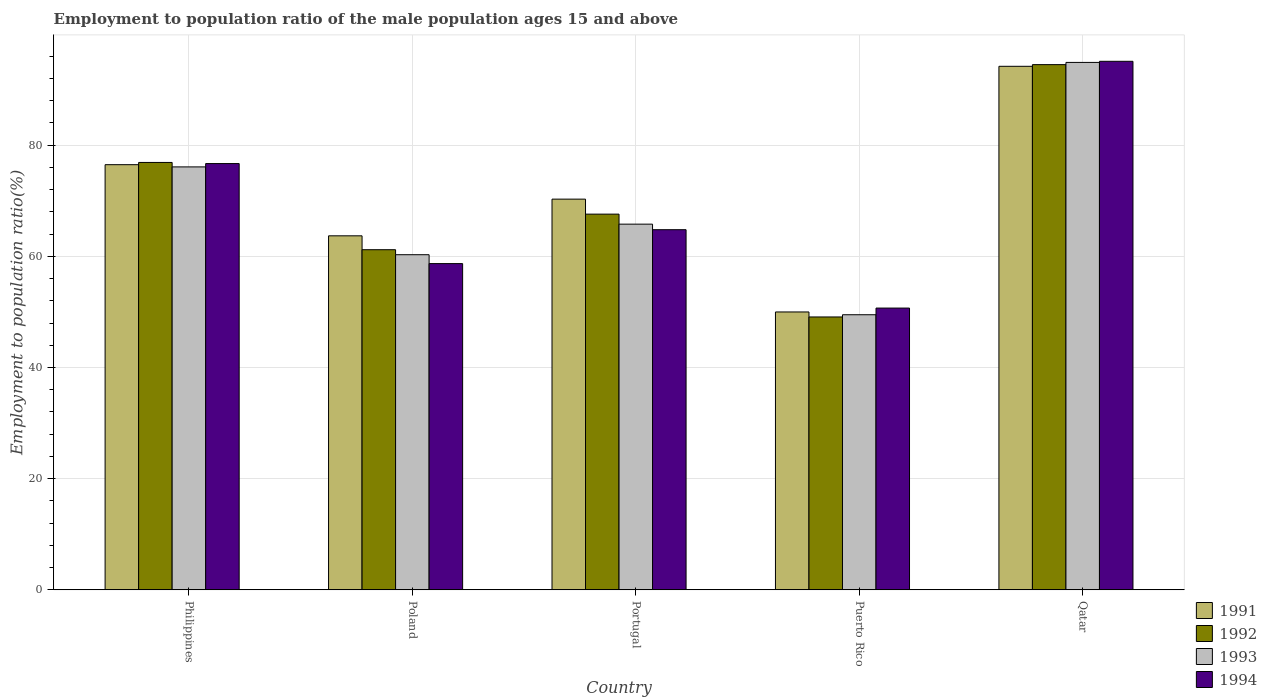How many different coloured bars are there?
Give a very brief answer. 4. How many groups of bars are there?
Your response must be concise. 5. Are the number of bars per tick equal to the number of legend labels?
Your answer should be very brief. Yes. How many bars are there on the 2nd tick from the right?
Your response must be concise. 4. What is the label of the 5th group of bars from the left?
Offer a terse response. Qatar. What is the employment to population ratio in 1991 in Qatar?
Keep it short and to the point. 94.2. Across all countries, what is the maximum employment to population ratio in 1992?
Ensure brevity in your answer.  94.5. Across all countries, what is the minimum employment to population ratio in 1993?
Ensure brevity in your answer.  49.5. In which country was the employment to population ratio in 1992 maximum?
Provide a succinct answer. Qatar. In which country was the employment to population ratio in 1993 minimum?
Provide a short and direct response. Puerto Rico. What is the total employment to population ratio in 1992 in the graph?
Your answer should be very brief. 349.3. What is the difference between the employment to population ratio in 1992 in Poland and that in Portugal?
Make the answer very short. -6.4. What is the difference between the employment to population ratio in 1993 in Qatar and the employment to population ratio in 1994 in Philippines?
Ensure brevity in your answer.  18.2. What is the average employment to population ratio in 1992 per country?
Offer a terse response. 69.86. In how many countries, is the employment to population ratio in 1994 greater than 44 %?
Offer a very short reply. 5. What is the ratio of the employment to population ratio in 1991 in Poland to that in Qatar?
Your answer should be compact. 0.68. Is the difference between the employment to population ratio in 1992 in Philippines and Qatar greater than the difference between the employment to population ratio in 1991 in Philippines and Qatar?
Keep it short and to the point. Yes. What is the difference between the highest and the second highest employment to population ratio in 1994?
Offer a very short reply. -11.9. What is the difference between the highest and the lowest employment to population ratio in 1992?
Your answer should be compact. 45.4. How many bars are there?
Provide a succinct answer. 20. Are all the bars in the graph horizontal?
Provide a short and direct response. No. How many countries are there in the graph?
Your response must be concise. 5. Where does the legend appear in the graph?
Give a very brief answer. Bottom right. How many legend labels are there?
Provide a succinct answer. 4. What is the title of the graph?
Make the answer very short. Employment to population ratio of the male population ages 15 and above. Does "1964" appear as one of the legend labels in the graph?
Provide a short and direct response. No. What is the Employment to population ratio(%) of 1991 in Philippines?
Provide a succinct answer. 76.5. What is the Employment to population ratio(%) of 1992 in Philippines?
Keep it short and to the point. 76.9. What is the Employment to population ratio(%) of 1993 in Philippines?
Keep it short and to the point. 76.1. What is the Employment to population ratio(%) in 1994 in Philippines?
Provide a short and direct response. 76.7. What is the Employment to population ratio(%) of 1991 in Poland?
Offer a very short reply. 63.7. What is the Employment to population ratio(%) in 1992 in Poland?
Keep it short and to the point. 61.2. What is the Employment to population ratio(%) in 1993 in Poland?
Offer a very short reply. 60.3. What is the Employment to population ratio(%) in 1994 in Poland?
Make the answer very short. 58.7. What is the Employment to population ratio(%) in 1991 in Portugal?
Provide a short and direct response. 70.3. What is the Employment to population ratio(%) in 1992 in Portugal?
Offer a terse response. 67.6. What is the Employment to population ratio(%) of 1993 in Portugal?
Provide a succinct answer. 65.8. What is the Employment to population ratio(%) of 1994 in Portugal?
Provide a succinct answer. 64.8. What is the Employment to population ratio(%) of 1991 in Puerto Rico?
Your answer should be compact. 50. What is the Employment to population ratio(%) in 1992 in Puerto Rico?
Your answer should be compact. 49.1. What is the Employment to population ratio(%) of 1993 in Puerto Rico?
Your response must be concise. 49.5. What is the Employment to population ratio(%) in 1994 in Puerto Rico?
Ensure brevity in your answer.  50.7. What is the Employment to population ratio(%) in 1991 in Qatar?
Your response must be concise. 94.2. What is the Employment to population ratio(%) of 1992 in Qatar?
Your answer should be compact. 94.5. What is the Employment to population ratio(%) in 1993 in Qatar?
Ensure brevity in your answer.  94.9. What is the Employment to population ratio(%) in 1994 in Qatar?
Provide a succinct answer. 95.1. Across all countries, what is the maximum Employment to population ratio(%) of 1991?
Offer a very short reply. 94.2. Across all countries, what is the maximum Employment to population ratio(%) in 1992?
Provide a short and direct response. 94.5. Across all countries, what is the maximum Employment to population ratio(%) of 1993?
Your response must be concise. 94.9. Across all countries, what is the maximum Employment to population ratio(%) in 1994?
Ensure brevity in your answer.  95.1. Across all countries, what is the minimum Employment to population ratio(%) in 1991?
Your answer should be very brief. 50. Across all countries, what is the minimum Employment to population ratio(%) in 1992?
Offer a very short reply. 49.1. Across all countries, what is the minimum Employment to population ratio(%) of 1993?
Offer a terse response. 49.5. Across all countries, what is the minimum Employment to population ratio(%) of 1994?
Provide a short and direct response. 50.7. What is the total Employment to population ratio(%) of 1991 in the graph?
Your answer should be very brief. 354.7. What is the total Employment to population ratio(%) of 1992 in the graph?
Make the answer very short. 349.3. What is the total Employment to population ratio(%) of 1993 in the graph?
Provide a succinct answer. 346.6. What is the total Employment to population ratio(%) of 1994 in the graph?
Your answer should be very brief. 346. What is the difference between the Employment to population ratio(%) of 1991 in Philippines and that in Portugal?
Keep it short and to the point. 6.2. What is the difference between the Employment to population ratio(%) of 1992 in Philippines and that in Portugal?
Your answer should be compact. 9.3. What is the difference between the Employment to population ratio(%) in 1992 in Philippines and that in Puerto Rico?
Ensure brevity in your answer.  27.8. What is the difference between the Employment to population ratio(%) in 1993 in Philippines and that in Puerto Rico?
Provide a short and direct response. 26.6. What is the difference between the Employment to population ratio(%) of 1991 in Philippines and that in Qatar?
Ensure brevity in your answer.  -17.7. What is the difference between the Employment to population ratio(%) of 1992 in Philippines and that in Qatar?
Provide a short and direct response. -17.6. What is the difference between the Employment to population ratio(%) in 1993 in Philippines and that in Qatar?
Ensure brevity in your answer.  -18.8. What is the difference between the Employment to population ratio(%) in 1994 in Philippines and that in Qatar?
Provide a short and direct response. -18.4. What is the difference between the Employment to population ratio(%) in 1992 in Poland and that in Portugal?
Keep it short and to the point. -6.4. What is the difference between the Employment to population ratio(%) in 1993 in Poland and that in Portugal?
Offer a very short reply. -5.5. What is the difference between the Employment to population ratio(%) of 1994 in Poland and that in Portugal?
Your answer should be compact. -6.1. What is the difference between the Employment to population ratio(%) in 1993 in Poland and that in Puerto Rico?
Your answer should be very brief. 10.8. What is the difference between the Employment to population ratio(%) in 1994 in Poland and that in Puerto Rico?
Offer a terse response. 8. What is the difference between the Employment to population ratio(%) in 1991 in Poland and that in Qatar?
Your response must be concise. -30.5. What is the difference between the Employment to population ratio(%) in 1992 in Poland and that in Qatar?
Ensure brevity in your answer.  -33.3. What is the difference between the Employment to population ratio(%) of 1993 in Poland and that in Qatar?
Keep it short and to the point. -34.6. What is the difference between the Employment to population ratio(%) in 1994 in Poland and that in Qatar?
Ensure brevity in your answer.  -36.4. What is the difference between the Employment to population ratio(%) in 1991 in Portugal and that in Puerto Rico?
Your response must be concise. 20.3. What is the difference between the Employment to population ratio(%) in 1991 in Portugal and that in Qatar?
Offer a very short reply. -23.9. What is the difference between the Employment to population ratio(%) in 1992 in Portugal and that in Qatar?
Give a very brief answer. -26.9. What is the difference between the Employment to population ratio(%) in 1993 in Portugal and that in Qatar?
Keep it short and to the point. -29.1. What is the difference between the Employment to population ratio(%) in 1994 in Portugal and that in Qatar?
Provide a succinct answer. -30.3. What is the difference between the Employment to population ratio(%) in 1991 in Puerto Rico and that in Qatar?
Your response must be concise. -44.2. What is the difference between the Employment to population ratio(%) of 1992 in Puerto Rico and that in Qatar?
Your answer should be compact. -45.4. What is the difference between the Employment to population ratio(%) of 1993 in Puerto Rico and that in Qatar?
Make the answer very short. -45.4. What is the difference between the Employment to population ratio(%) of 1994 in Puerto Rico and that in Qatar?
Provide a succinct answer. -44.4. What is the difference between the Employment to population ratio(%) in 1991 in Philippines and the Employment to population ratio(%) in 1994 in Poland?
Give a very brief answer. 17.8. What is the difference between the Employment to population ratio(%) in 1992 in Philippines and the Employment to population ratio(%) in 1993 in Poland?
Ensure brevity in your answer.  16.6. What is the difference between the Employment to population ratio(%) in 1992 in Philippines and the Employment to population ratio(%) in 1994 in Poland?
Ensure brevity in your answer.  18.2. What is the difference between the Employment to population ratio(%) of 1993 in Philippines and the Employment to population ratio(%) of 1994 in Poland?
Your answer should be compact. 17.4. What is the difference between the Employment to population ratio(%) in 1991 in Philippines and the Employment to population ratio(%) in 1993 in Portugal?
Provide a succinct answer. 10.7. What is the difference between the Employment to population ratio(%) of 1991 in Philippines and the Employment to population ratio(%) of 1994 in Portugal?
Make the answer very short. 11.7. What is the difference between the Employment to population ratio(%) in 1992 in Philippines and the Employment to population ratio(%) in 1993 in Portugal?
Offer a very short reply. 11.1. What is the difference between the Employment to population ratio(%) of 1991 in Philippines and the Employment to population ratio(%) of 1992 in Puerto Rico?
Provide a short and direct response. 27.4. What is the difference between the Employment to population ratio(%) of 1991 in Philippines and the Employment to population ratio(%) of 1994 in Puerto Rico?
Your answer should be very brief. 25.8. What is the difference between the Employment to population ratio(%) in 1992 in Philippines and the Employment to population ratio(%) in 1993 in Puerto Rico?
Your response must be concise. 27.4. What is the difference between the Employment to population ratio(%) of 1992 in Philippines and the Employment to population ratio(%) of 1994 in Puerto Rico?
Your response must be concise. 26.2. What is the difference between the Employment to population ratio(%) of 1993 in Philippines and the Employment to population ratio(%) of 1994 in Puerto Rico?
Your answer should be compact. 25.4. What is the difference between the Employment to population ratio(%) in 1991 in Philippines and the Employment to population ratio(%) in 1993 in Qatar?
Ensure brevity in your answer.  -18.4. What is the difference between the Employment to population ratio(%) in 1991 in Philippines and the Employment to population ratio(%) in 1994 in Qatar?
Ensure brevity in your answer.  -18.6. What is the difference between the Employment to population ratio(%) in 1992 in Philippines and the Employment to population ratio(%) in 1993 in Qatar?
Offer a very short reply. -18. What is the difference between the Employment to population ratio(%) in 1992 in Philippines and the Employment to population ratio(%) in 1994 in Qatar?
Your response must be concise. -18.2. What is the difference between the Employment to population ratio(%) in 1991 in Poland and the Employment to population ratio(%) in 1993 in Portugal?
Your response must be concise. -2.1. What is the difference between the Employment to population ratio(%) of 1991 in Poland and the Employment to population ratio(%) of 1994 in Portugal?
Ensure brevity in your answer.  -1.1. What is the difference between the Employment to population ratio(%) of 1992 in Poland and the Employment to population ratio(%) of 1993 in Portugal?
Offer a very short reply. -4.6. What is the difference between the Employment to population ratio(%) in 1993 in Poland and the Employment to population ratio(%) in 1994 in Puerto Rico?
Give a very brief answer. 9.6. What is the difference between the Employment to population ratio(%) in 1991 in Poland and the Employment to population ratio(%) in 1992 in Qatar?
Your answer should be very brief. -30.8. What is the difference between the Employment to population ratio(%) in 1991 in Poland and the Employment to population ratio(%) in 1993 in Qatar?
Provide a succinct answer. -31.2. What is the difference between the Employment to population ratio(%) of 1991 in Poland and the Employment to population ratio(%) of 1994 in Qatar?
Keep it short and to the point. -31.4. What is the difference between the Employment to population ratio(%) of 1992 in Poland and the Employment to population ratio(%) of 1993 in Qatar?
Provide a short and direct response. -33.7. What is the difference between the Employment to population ratio(%) of 1992 in Poland and the Employment to population ratio(%) of 1994 in Qatar?
Offer a terse response. -33.9. What is the difference between the Employment to population ratio(%) in 1993 in Poland and the Employment to population ratio(%) in 1994 in Qatar?
Offer a very short reply. -34.8. What is the difference between the Employment to population ratio(%) in 1991 in Portugal and the Employment to population ratio(%) in 1992 in Puerto Rico?
Your answer should be compact. 21.2. What is the difference between the Employment to population ratio(%) in 1991 in Portugal and the Employment to population ratio(%) in 1993 in Puerto Rico?
Give a very brief answer. 20.8. What is the difference between the Employment to population ratio(%) of 1991 in Portugal and the Employment to population ratio(%) of 1994 in Puerto Rico?
Offer a very short reply. 19.6. What is the difference between the Employment to population ratio(%) in 1993 in Portugal and the Employment to population ratio(%) in 1994 in Puerto Rico?
Your response must be concise. 15.1. What is the difference between the Employment to population ratio(%) in 1991 in Portugal and the Employment to population ratio(%) in 1992 in Qatar?
Your answer should be compact. -24.2. What is the difference between the Employment to population ratio(%) in 1991 in Portugal and the Employment to population ratio(%) in 1993 in Qatar?
Your answer should be very brief. -24.6. What is the difference between the Employment to population ratio(%) of 1991 in Portugal and the Employment to population ratio(%) of 1994 in Qatar?
Offer a very short reply. -24.8. What is the difference between the Employment to population ratio(%) of 1992 in Portugal and the Employment to population ratio(%) of 1993 in Qatar?
Your answer should be compact. -27.3. What is the difference between the Employment to population ratio(%) of 1992 in Portugal and the Employment to population ratio(%) of 1994 in Qatar?
Your answer should be very brief. -27.5. What is the difference between the Employment to population ratio(%) in 1993 in Portugal and the Employment to population ratio(%) in 1994 in Qatar?
Your response must be concise. -29.3. What is the difference between the Employment to population ratio(%) in 1991 in Puerto Rico and the Employment to population ratio(%) in 1992 in Qatar?
Your response must be concise. -44.5. What is the difference between the Employment to population ratio(%) of 1991 in Puerto Rico and the Employment to population ratio(%) of 1993 in Qatar?
Offer a terse response. -44.9. What is the difference between the Employment to population ratio(%) of 1991 in Puerto Rico and the Employment to population ratio(%) of 1994 in Qatar?
Ensure brevity in your answer.  -45.1. What is the difference between the Employment to population ratio(%) of 1992 in Puerto Rico and the Employment to population ratio(%) of 1993 in Qatar?
Ensure brevity in your answer.  -45.8. What is the difference between the Employment to population ratio(%) of 1992 in Puerto Rico and the Employment to population ratio(%) of 1994 in Qatar?
Your answer should be very brief. -46. What is the difference between the Employment to population ratio(%) of 1993 in Puerto Rico and the Employment to population ratio(%) of 1994 in Qatar?
Provide a short and direct response. -45.6. What is the average Employment to population ratio(%) in 1991 per country?
Give a very brief answer. 70.94. What is the average Employment to population ratio(%) of 1992 per country?
Offer a terse response. 69.86. What is the average Employment to population ratio(%) in 1993 per country?
Ensure brevity in your answer.  69.32. What is the average Employment to population ratio(%) in 1994 per country?
Ensure brevity in your answer.  69.2. What is the difference between the Employment to population ratio(%) of 1991 and Employment to population ratio(%) of 1992 in Philippines?
Keep it short and to the point. -0.4. What is the difference between the Employment to population ratio(%) of 1991 and Employment to population ratio(%) of 1994 in Philippines?
Provide a succinct answer. -0.2. What is the difference between the Employment to population ratio(%) in 1992 and Employment to population ratio(%) in 1993 in Philippines?
Your response must be concise. 0.8. What is the difference between the Employment to population ratio(%) of 1992 and Employment to population ratio(%) of 1994 in Philippines?
Provide a succinct answer. 0.2. What is the difference between the Employment to population ratio(%) of 1993 and Employment to population ratio(%) of 1994 in Philippines?
Your answer should be compact. -0.6. What is the difference between the Employment to population ratio(%) in 1991 and Employment to population ratio(%) in 1993 in Poland?
Offer a very short reply. 3.4. What is the difference between the Employment to population ratio(%) of 1992 and Employment to population ratio(%) of 1994 in Poland?
Provide a succinct answer. 2.5. What is the difference between the Employment to population ratio(%) in 1993 and Employment to population ratio(%) in 1994 in Poland?
Your answer should be compact. 1.6. What is the difference between the Employment to population ratio(%) in 1991 and Employment to population ratio(%) in 1992 in Portugal?
Your answer should be compact. 2.7. What is the difference between the Employment to population ratio(%) of 1991 and Employment to population ratio(%) of 1993 in Portugal?
Offer a terse response. 4.5. What is the difference between the Employment to population ratio(%) in 1991 and Employment to population ratio(%) in 1994 in Portugal?
Your answer should be compact. 5.5. What is the difference between the Employment to population ratio(%) of 1992 and Employment to population ratio(%) of 1994 in Portugal?
Keep it short and to the point. 2.8. What is the difference between the Employment to population ratio(%) of 1993 and Employment to population ratio(%) of 1994 in Portugal?
Provide a short and direct response. 1. What is the difference between the Employment to population ratio(%) in 1991 and Employment to population ratio(%) in 1992 in Puerto Rico?
Your response must be concise. 0.9. What is the difference between the Employment to population ratio(%) in 1991 and Employment to population ratio(%) in 1994 in Puerto Rico?
Provide a succinct answer. -0.7. What is the difference between the Employment to population ratio(%) of 1992 and Employment to population ratio(%) of 1994 in Puerto Rico?
Ensure brevity in your answer.  -1.6. What is the difference between the Employment to population ratio(%) of 1992 and Employment to population ratio(%) of 1993 in Qatar?
Provide a succinct answer. -0.4. What is the difference between the Employment to population ratio(%) in 1992 and Employment to population ratio(%) in 1994 in Qatar?
Offer a terse response. -0.6. What is the ratio of the Employment to population ratio(%) in 1991 in Philippines to that in Poland?
Offer a very short reply. 1.2. What is the ratio of the Employment to population ratio(%) of 1992 in Philippines to that in Poland?
Keep it short and to the point. 1.26. What is the ratio of the Employment to population ratio(%) of 1993 in Philippines to that in Poland?
Offer a terse response. 1.26. What is the ratio of the Employment to population ratio(%) in 1994 in Philippines to that in Poland?
Provide a short and direct response. 1.31. What is the ratio of the Employment to population ratio(%) of 1991 in Philippines to that in Portugal?
Keep it short and to the point. 1.09. What is the ratio of the Employment to population ratio(%) in 1992 in Philippines to that in Portugal?
Give a very brief answer. 1.14. What is the ratio of the Employment to population ratio(%) of 1993 in Philippines to that in Portugal?
Give a very brief answer. 1.16. What is the ratio of the Employment to population ratio(%) in 1994 in Philippines to that in Portugal?
Provide a short and direct response. 1.18. What is the ratio of the Employment to population ratio(%) in 1991 in Philippines to that in Puerto Rico?
Your response must be concise. 1.53. What is the ratio of the Employment to population ratio(%) of 1992 in Philippines to that in Puerto Rico?
Your answer should be very brief. 1.57. What is the ratio of the Employment to population ratio(%) in 1993 in Philippines to that in Puerto Rico?
Your response must be concise. 1.54. What is the ratio of the Employment to population ratio(%) of 1994 in Philippines to that in Puerto Rico?
Offer a very short reply. 1.51. What is the ratio of the Employment to population ratio(%) in 1991 in Philippines to that in Qatar?
Offer a very short reply. 0.81. What is the ratio of the Employment to population ratio(%) of 1992 in Philippines to that in Qatar?
Make the answer very short. 0.81. What is the ratio of the Employment to population ratio(%) in 1993 in Philippines to that in Qatar?
Offer a terse response. 0.8. What is the ratio of the Employment to population ratio(%) of 1994 in Philippines to that in Qatar?
Offer a terse response. 0.81. What is the ratio of the Employment to population ratio(%) of 1991 in Poland to that in Portugal?
Offer a very short reply. 0.91. What is the ratio of the Employment to population ratio(%) of 1992 in Poland to that in Portugal?
Keep it short and to the point. 0.91. What is the ratio of the Employment to population ratio(%) in 1993 in Poland to that in Portugal?
Give a very brief answer. 0.92. What is the ratio of the Employment to population ratio(%) of 1994 in Poland to that in Portugal?
Give a very brief answer. 0.91. What is the ratio of the Employment to population ratio(%) in 1991 in Poland to that in Puerto Rico?
Your answer should be compact. 1.27. What is the ratio of the Employment to population ratio(%) of 1992 in Poland to that in Puerto Rico?
Your answer should be compact. 1.25. What is the ratio of the Employment to population ratio(%) in 1993 in Poland to that in Puerto Rico?
Your answer should be very brief. 1.22. What is the ratio of the Employment to population ratio(%) of 1994 in Poland to that in Puerto Rico?
Offer a terse response. 1.16. What is the ratio of the Employment to population ratio(%) of 1991 in Poland to that in Qatar?
Provide a succinct answer. 0.68. What is the ratio of the Employment to population ratio(%) of 1992 in Poland to that in Qatar?
Make the answer very short. 0.65. What is the ratio of the Employment to population ratio(%) of 1993 in Poland to that in Qatar?
Give a very brief answer. 0.64. What is the ratio of the Employment to population ratio(%) of 1994 in Poland to that in Qatar?
Ensure brevity in your answer.  0.62. What is the ratio of the Employment to population ratio(%) in 1991 in Portugal to that in Puerto Rico?
Provide a short and direct response. 1.41. What is the ratio of the Employment to population ratio(%) of 1992 in Portugal to that in Puerto Rico?
Ensure brevity in your answer.  1.38. What is the ratio of the Employment to population ratio(%) in 1993 in Portugal to that in Puerto Rico?
Offer a very short reply. 1.33. What is the ratio of the Employment to population ratio(%) in 1994 in Portugal to that in Puerto Rico?
Your response must be concise. 1.28. What is the ratio of the Employment to population ratio(%) of 1991 in Portugal to that in Qatar?
Provide a short and direct response. 0.75. What is the ratio of the Employment to population ratio(%) of 1992 in Portugal to that in Qatar?
Ensure brevity in your answer.  0.72. What is the ratio of the Employment to population ratio(%) in 1993 in Portugal to that in Qatar?
Provide a succinct answer. 0.69. What is the ratio of the Employment to population ratio(%) in 1994 in Portugal to that in Qatar?
Ensure brevity in your answer.  0.68. What is the ratio of the Employment to population ratio(%) in 1991 in Puerto Rico to that in Qatar?
Your response must be concise. 0.53. What is the ratio of the Employment to population ratio(%) of 1992 in Puerto Rico to that in Qatar?
Your answer should be compact. 0.52. What is the ratio of the Employment to population ratio(%) of 1993 in Puerto Rico to that in Qatar?
Offer a terse response. 0.52. What is the ratio of the Employment to population ratio(%) in 1994 in Puerto Rico to that in Qatar?
Your answer should be compact. 0.53. What is the difference between the highest and the second highest Employment to population ratio(%) of 1991?
Ensure brevity in your answer.  17.7. What is the difference between the highest and the second highest Employment to population ratio(%) in 1994?
Your answer should be compact. 18.4. What is the difference between the highest and the lowest Employment to population ratio(%) in 1991?
Provide a succinct answer. 44.2. What is the difference between the highest and the lowest Employment to population ratio(%) in 1992?
Your answer should be very brief. 45.4. What is the difference between the highest and the lowest Employment to population ratio(%) of 1993?
Offer a very short reply. 45.4. What is the difference between the highest and the lowest Employment to population ratio(%) in 1994?
Your answer should be compact. 44.4. 